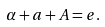Convert formula to latex. <formula><loc_0><loc_0><loc_500><loc_500>\alpha + a + A = e .</formula> 